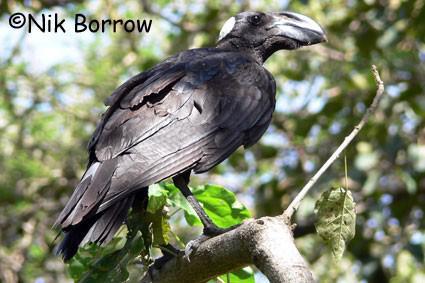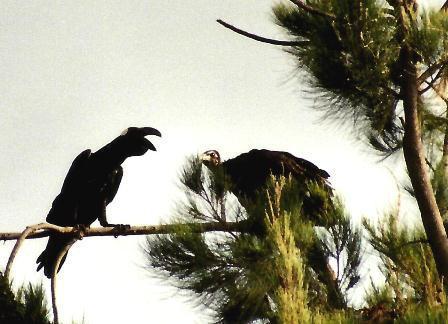The first image is the image on the left, the second image is the image on the right. Considering the images on both sides, is "Large groups of vultures are gathered on walls of wood or brick in one of the images." valid? Answer yes or no. No. The first image is the image on the left, the second image is the image on the right. Given the left and right images, does the statement "One of the images shows exactly one bird perched on a branch." hold true? Answer yes or no. Yes. The first image is the image on the left, the second image is the image on the right. Considering the images on both sides, is "An image shows one dark bird perched on a horizontal tree branch." valid? Answer yes or no. Yes. The first image is the image on the left, the second image is the image on the right. For the images displayed, is the sentence "There are at most three ravens standing on a branch" factually correct? Answer yes or no. Yes. 